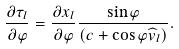Convert formula to latex. <formula><loc_0><loc_0><loc_500><loc_500>\frac { \partial \tau _ { l } } { \partial \varphi } = \frac { \partial x _ { l } } { \partial \varphi } \frac { \sin \varphi } { ( c + \cos \varphi \widehat { v } _ { l } ) } .</formula> 